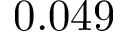<formula> <loc_0><loc_0><loc_500><loc_500>0 . 0 4 9</formula> 